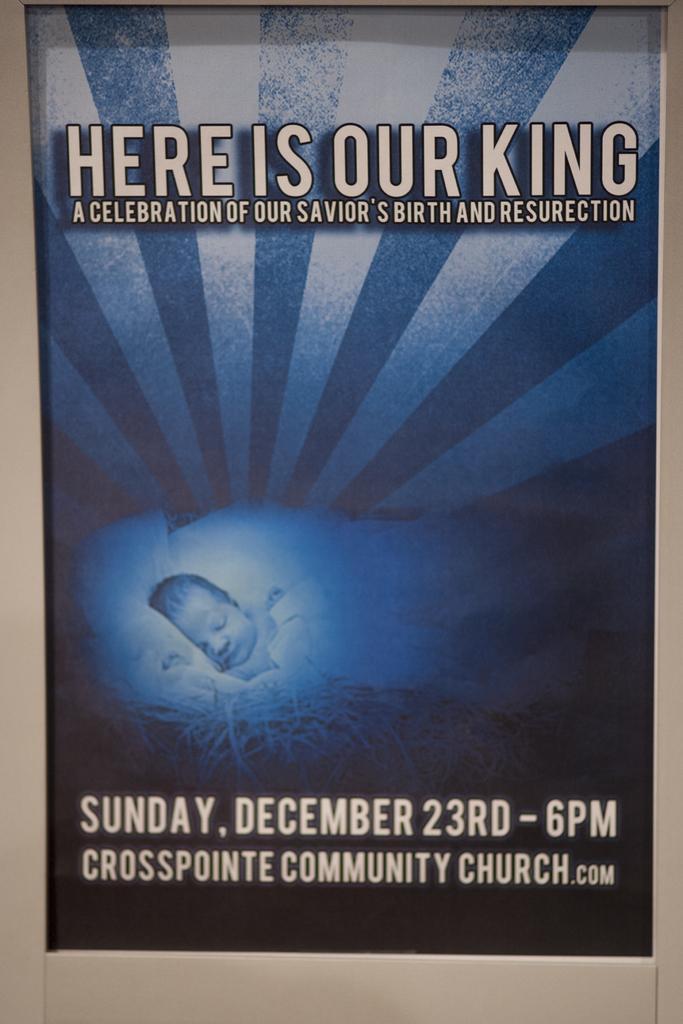In one or two sentences, can you explain what this image depicts? In this image we can see there is a poster with some text. 